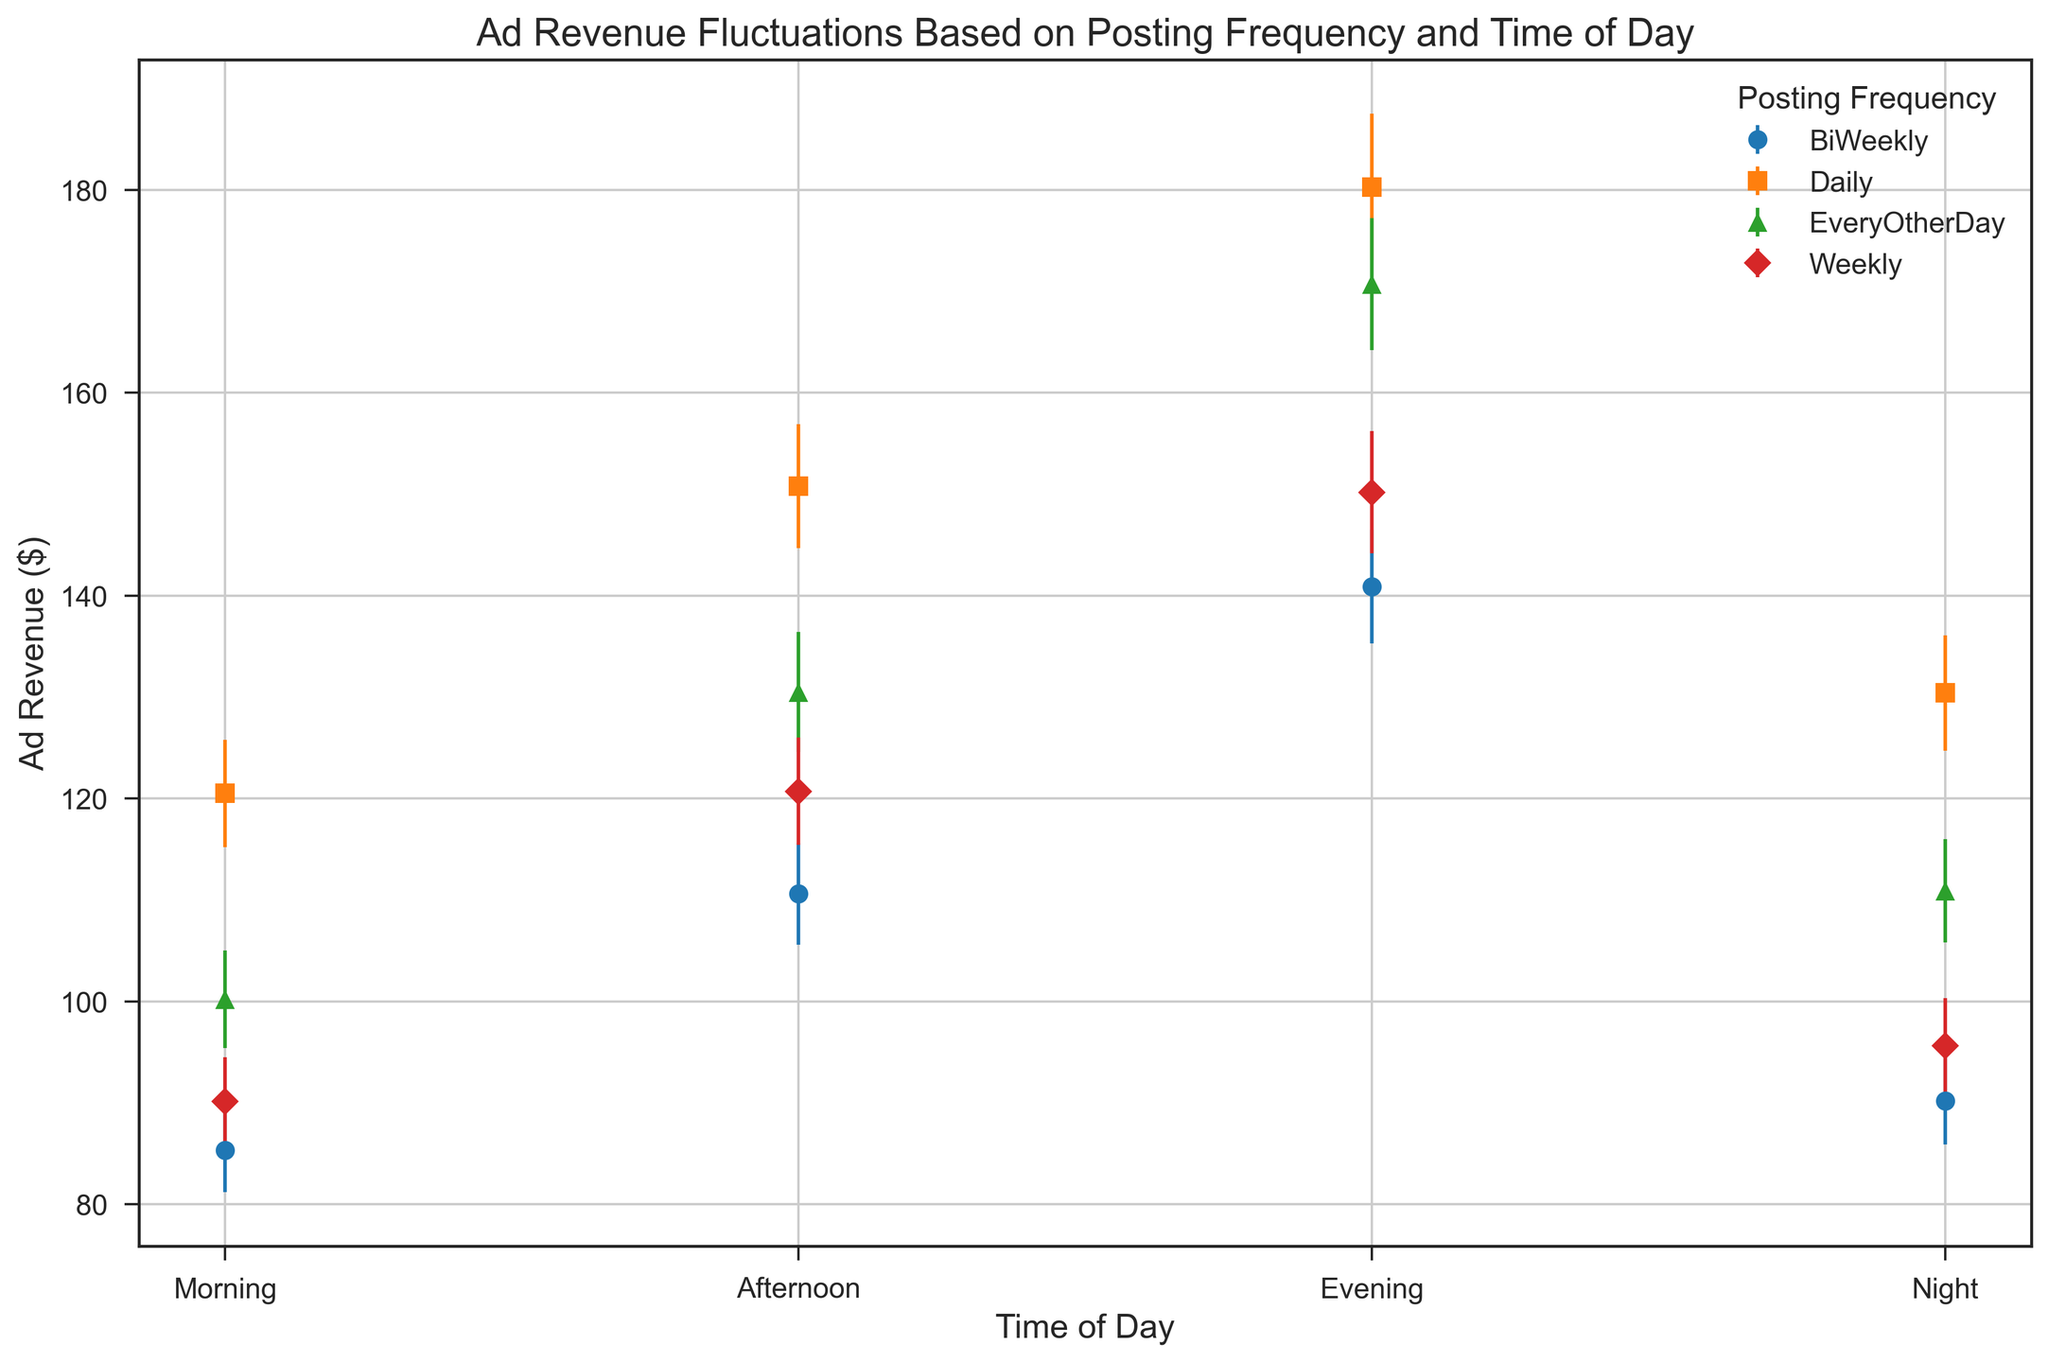Which posting frequency yields the highest ad revenue on average? To find this, calculate the average ad revenue for each posting frequency and then compare them. For Daily: (120.5 + 150.8 + 180.3 + 130.4)/4 = 145.5. For EveryOtherDay: (100.2 + 130.5 + 170.7 + 110.9)/4 = 128.1. For Weekly: (90.1 + 120.7 + 150.2 + 95.6)/4 = 114.15. For BiWeekly: (85.3 + 110.6 + 140.9 + 90.2)/4 = 106.75. So, Daily has the highest average ad revenue.
Answer: Daily During which time of day is the ad revenue most variable for weekly postings? Look for the highest error bar among the weekly postings data points. The error bars for weekly postings are: Morning: 4.4, Afternoon: 5.3, Evening: 6.0, Night: 4.7. The highest error is 6.0 in the Evening.
Answer: Evening Which combination of posting frequency and time of day gives the lowest ad revenue? Compare all the ad revenue values to find the smallest one. The smallest value is 85.3 for BiWeekly in the Morning.
Answer: BiWeekly, Morning How does the ad revenue compare between Daily and EveryOtherDay posting frequencies in the Evening? Compare the values at the Evening time for both frequencies. Daily posting in the Evening: 180.3. EveryOtherDay posting in the Evening: 170.7. Daily has a higher ad revenue in the Evening than EveryOtherDay.
Answer: Daily has higher revenue What's the total ad revenue for Weekly postings? Sum all the ad revenue values for Weekly postings. Weekly postings: 90.1 (Morning) + 120.7 (Afternoon) + 150.2 (Evening) + 95.6 (Night). Total = 456.6.
Answer: 456.6 Which time of day has the highest average ad revenue regardless of posting frequency? Calculate the average ad revenue for each time of day. Morning: (120.5 + 100.2 + 90.1 + 85.3)/4 = 99.03. Afternoon: (150.8 + 130.5 + 120.7 + 110.6)/4 = 128.15. Evening: (180.3 + 170.7 + 150.2 + 140.9)/4 = 160.53. Night: (130.4 + 110.9 + 95.6 + 90.2)/4 = 106.775. The highest average ad revenue is in the Evening.
Answer: Evening Compare the ad revenue variability for BiWeekly postings in the Morning and the Night. Look at the error values for BiWeekly postings in the Morning and Night. Morning: 4.1, Night: 4.3. The Night has a slightly higher variability than the Morning.
Answer: Night has higher variability Considering only Daily postings, during which time of day can the highest ad revenue be expected within the given error range? For Daily postings, the values are: Morning: 120.5 ± 5.3, Afternoon: 150.8 ± 6.1, Evening: 180.3 ± 7.2, Night: 130.4 ± 5.7. The highest possible value within the error range can be found as: Evening: 180.3 + 7.2 = 187.5.
Answer: Evening Which time of day shows relatively consistent ad revenue across different posting frequencies? Compare the error bars across all times of day and posting frequencies to find the smallest range of errors. Morning: 5.3, 4.8, 4.4, 4.1. Afternoon: 6.1, 5.9, 5.3, 5.0. Evening: 7.2, 6.5, 6.0, 5.6. Night: 5.7, 5.1, 4.7, 4.3. Morning has the smallest range of error values, indicating relatively consistent ad revenue.
Answer: Morning 